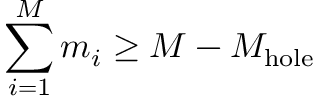<formula> <loc_0><loc_0><loc_500><loc_500>\sum _ { i = 1 } ^ { M } m _ { i } \geq M - M _ { h o l e }</formula> 